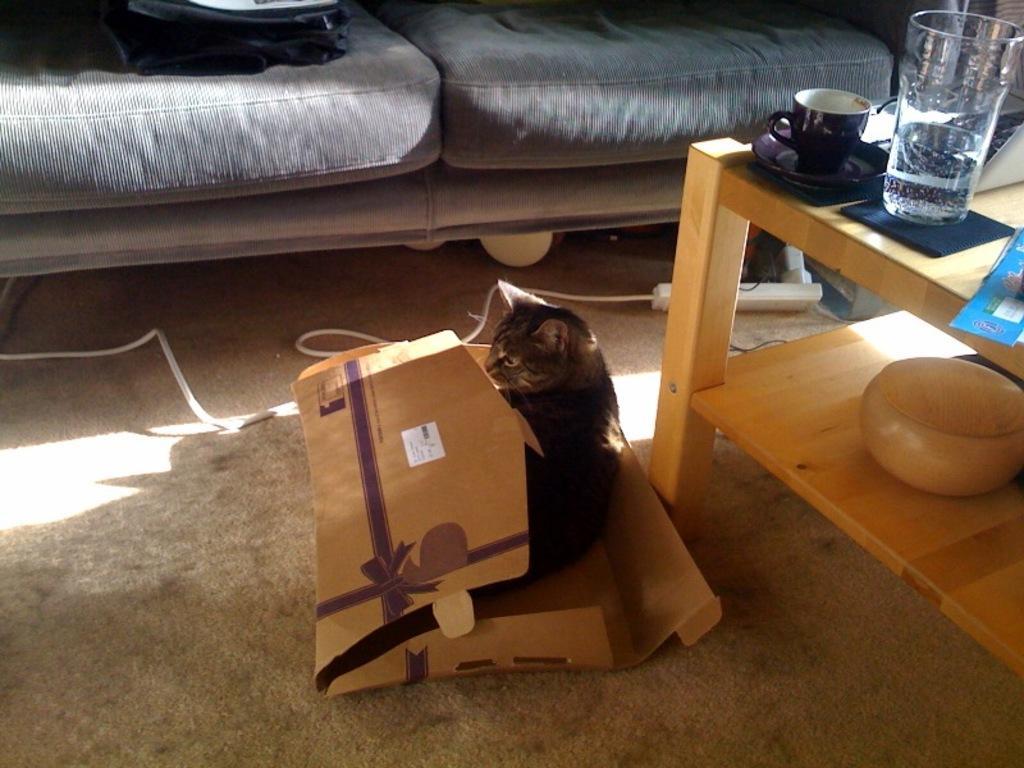How would you summarize this image in a sentence or two? This is a picture in living room. In the center of the picture there is a cat in the box. To the right there is a desk on the desk there is a cup, a saucer, a glass and a box and a book. In the background there is a couch and some objects. To the left there is a cable. 